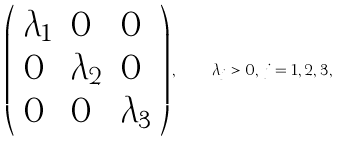Convert formula to latex. <formula><loc_0><loc_0><loc_500><loc_500>\left ( \begin{array} { l l l } \lambda _ { 1 } & 0 & 0 \\ 0 & \lambda _ { 2 } & 0 \\ 0 & 0 & \lambda _ { 3 } \end{array} \right ) , \quad \lambda _ { j } > 0 , \, j = 1 , 2 , 3 ,</formula> 